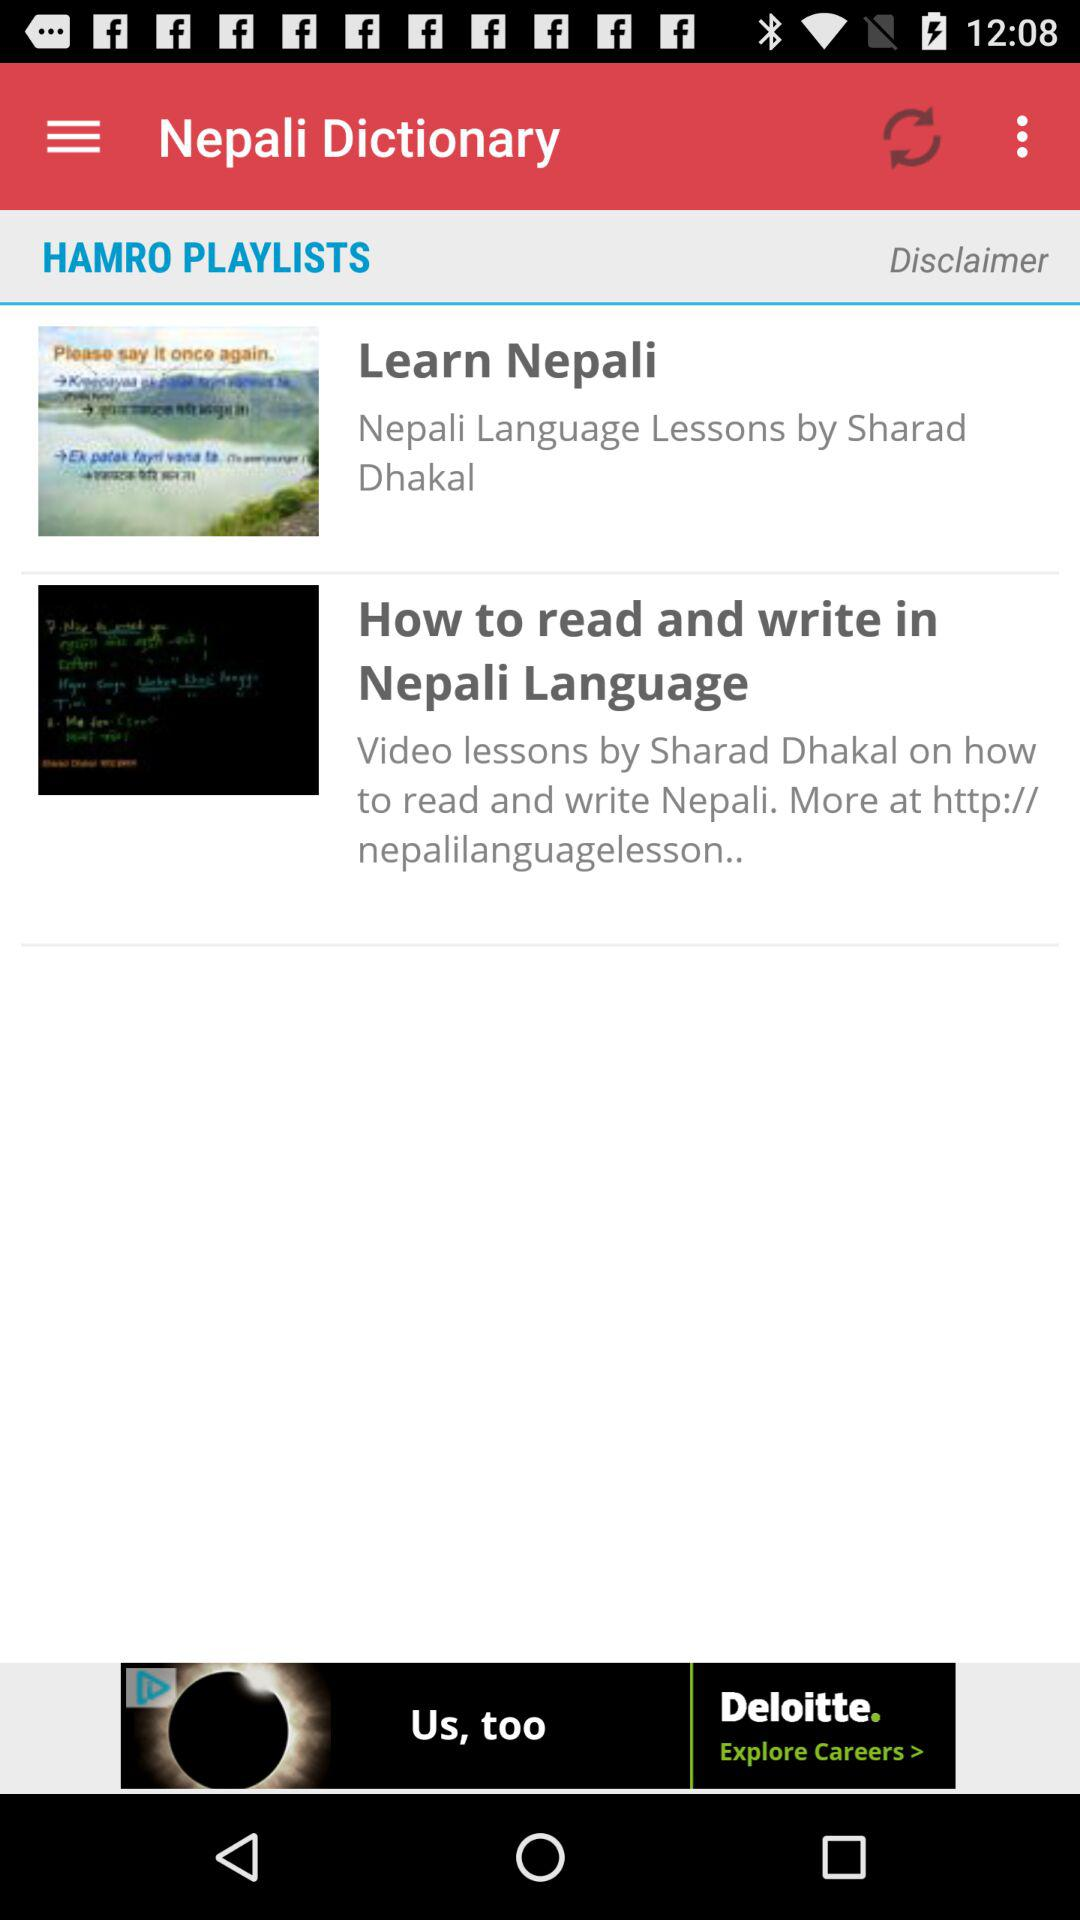What is the name of the playlist? The name of the playlist is "HAMRO PLAYLISTS". 